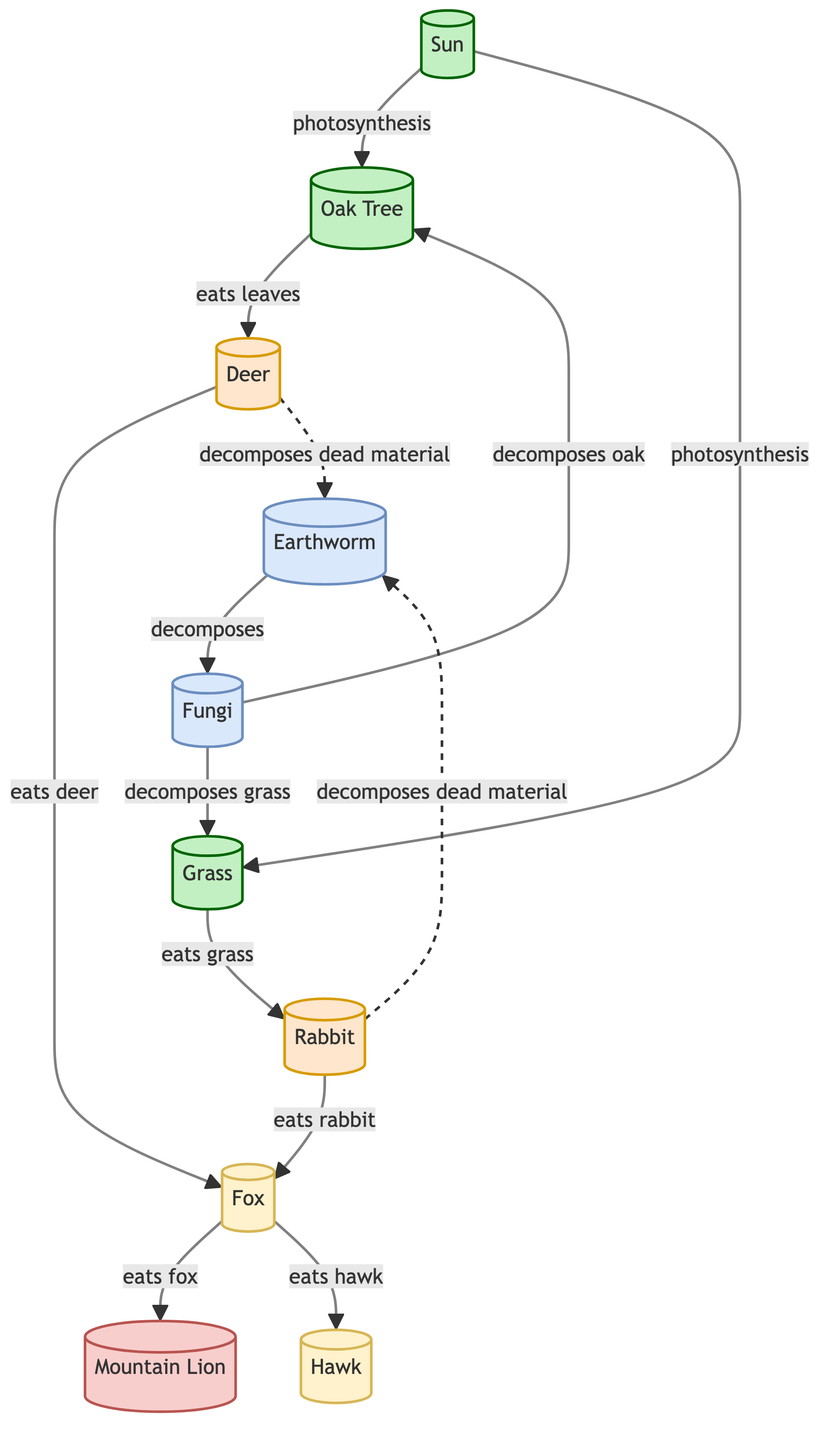What is the primary producer in the forest ecosystem? The diagram lists "Sun" and "Oak Tree" as producers, but the primary producer responsible for photosynthesis is the "Sun".
Answer: Sun How many primary consumers are present in the diagram? The nodes "Deer" and "Rabbit" are identified as primary consumers. Counting these, there are 2 primary consumers.
Answer: 2 Which animal is a secondary consumer that preys on rabbits? The arrow from "Rabbit" to "Fox" indicates that the "Fox" preys on "Rabbit", making it a secondary consumer in that context.
Answer: Fox What is the role of Earthworms in the ecosystem? The diagram indicates that Earthworms are decomposers that break down dead material, making them an essential part of the nutrient cycle.
Answer: Decomposer Which species has a direct interaction with both Fox and Hawk? Looking at the arrows, "Fox" interacts with both "Mountain Lion" and "Hawk" as it is a prey for "Mountain Lion" and it also preys on "Hawk".
Answer: Fox Explain the flow of energy from the Sun to a tertiary consumer. The Sun provides energy through photosynthesis to the Oak Tree, which is then eaten by Deer, which are then eaten by Fox, and finally, the Fox is eaten by the Mountain Lion, thus completing the flow of energy.
Answer: Mountain Lion How many decomposing species are mentioned in the food web? The food web includes "Earthworm" and "Fungi" as decomposers. Thus, there are two species involved in decomposition.
Answer: 2 Which species directly consumes grass according to the diagram? The connection from "Grass" points to "Rabbit," showing that rabbits eat grass, thus indicating the direct consumer.
Answer: Rabbit What does Fungi decompose in the food web? The diagram indicates that Fungi decompose both "oak" and "grass," pointing to its role in breaking down these organic materials.
Answer: Oak and Grass 